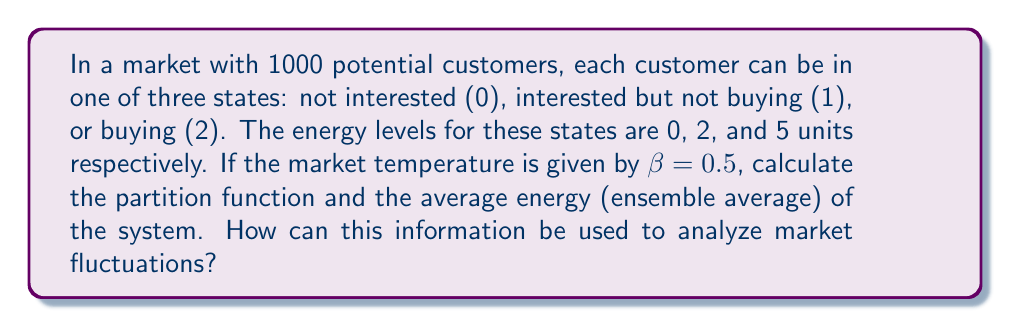Solve this math problem. 1. Calculate the partition function:
   The partition function $Z$ is given by:
   $$Z = \sum_{i} g_i e^{-\beta E_i}$$
   where $g_i$ is the degeneracy (number of states) and $E_i$ is the energy of state $i$.

   For our system:
   $$Z = 1000(e^{-0.5 \cdot 0} + e^{-0.5 \cdot 2} + e^{-0.5 \cdot 5})$$
   $$Z = 1000(1 + e^{-1} + e^{-2.5})$$
   $$Z = 1000(1 + 0.3679 + 0.0821) = 1450$$

2. Calculate the ensemble average energy:
   The ensemble average energy $\langle E \rangle$ is given by:
   $$\langle E \rangle = -\frac{\partial \ln Z}{\partial \beta}$$

   We can also calculate it using:
   $$\langle E \rangle = \frac{\sum_i E_i g_i e^{-\beta E_i}}{Z}$$

   $$\langle E \rangle = \frac{1000(0 \cdot 1 + 2 \cdot e^{-1} + 5 \cdot e^{-2.5})}{1450}$$
   $$\langle E \rangle = \frac{1000(0.7358 + 0.4105)}{1450} = 0.7907$$

3. Interpret the results:
   - The partition function (1450) represents the total number of possible microstates in the system.
   - The average energy (0.7907) represents the expected energy level of a typical customer in the market.
   - These values can be used to analyze market fluctuations by:
     a) Comparing partition functions over time to gauge overall market activity.
     b) Tracking changes in average energy to identify shifts in customer behavior.
     c) Calculating variance in energy to measure market volatility.
Answer: $Z = 1450$, $\langle E \rangle = 0.7907$ 